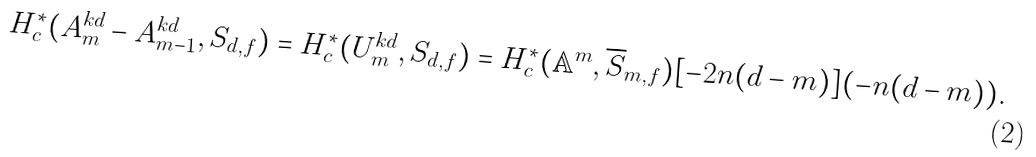<formula> <loc_0><loc_0><loc_500><loc_500>H ^ { * } _ { c } ( A _ { m } ^ { k d } - A _ { m - 1 } ^ { k d } , S _ { d , f } ) = H ^ { * } _ { c } ( U _ { m } ^ { k d } , S _ { d , f } ) & = H ^ { * } _ { c } ( \mathbb { A } ^ { m } , \overline { S } _ { m , f } ) [ - 2 n ( d - m ) ] ( - n ( d - m ) ) .</formula> 